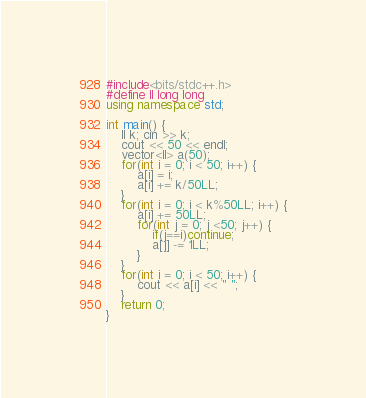<code> <loc_0><loc_0><loc_500><loc_500><_C++_>#include<bits/stdc++.h>
#define ll long long
using namespace std;

int main() {
    ll k; cin >> k;
    cout << 50 << endl;
    vector<ll> a(50);
    for(int i = 0; i < 50; i++) {
        a[i] = i;
        a[i] += k/50LL;
    }
    for(int i = 0; i < k%50LL; i++) {
        a[i] += 50LL;
        for(int j = 0; j <50; j++) {
            if(j==i)continue;
            a[j] -= 1LL;
        }
    }
    for(int i = 0; i < 50; i++) {
        cout << a[i] << " ";
    }
	return 0;
}
</code> 